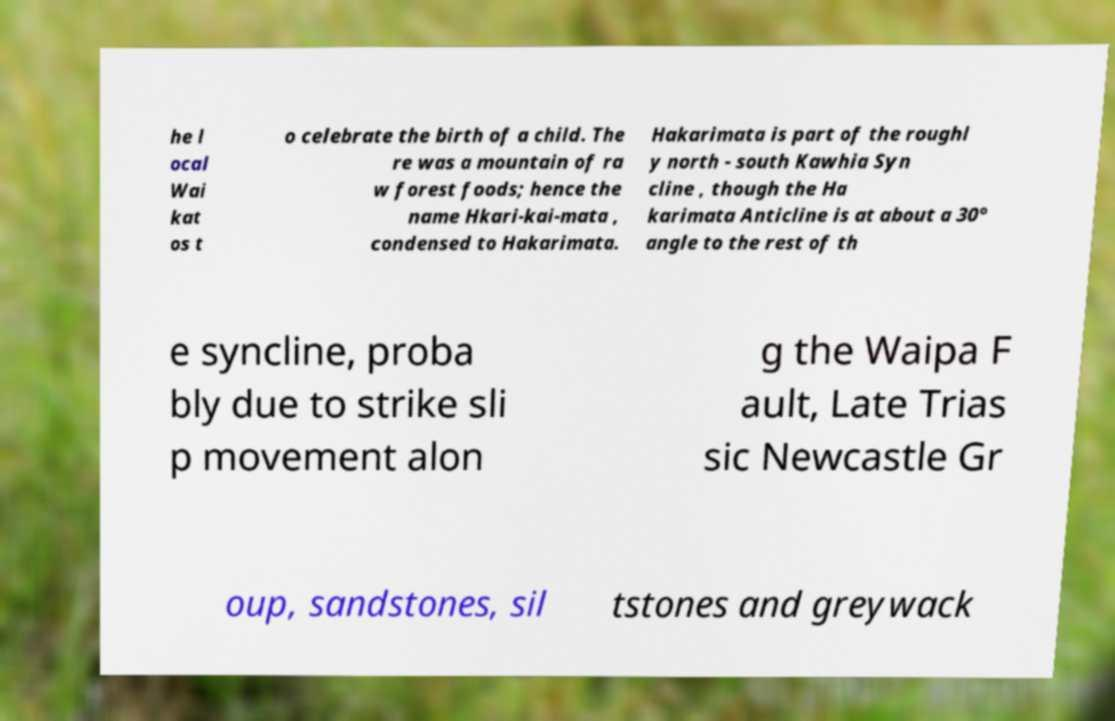For documentation purposes, I need the text within this image transcribed. Could you provide that? he l ocal Wai kat os t o celebrate the birth of a child. The re was a mountain of ra w forest foods; hence the name Hkari-kai-mata , condensed to Hakarimata. Hakarimata is part of the roughl y north - south Kawhia Syn cline , though the Ha karimata Anticline is at about a 30° angle to the rest of th e syncline, proba bly due to strike sli p movement alon g the Waipa F ault, Late Trias sic Newcastle Gr oup, sandstones, sil tstones and greywack 